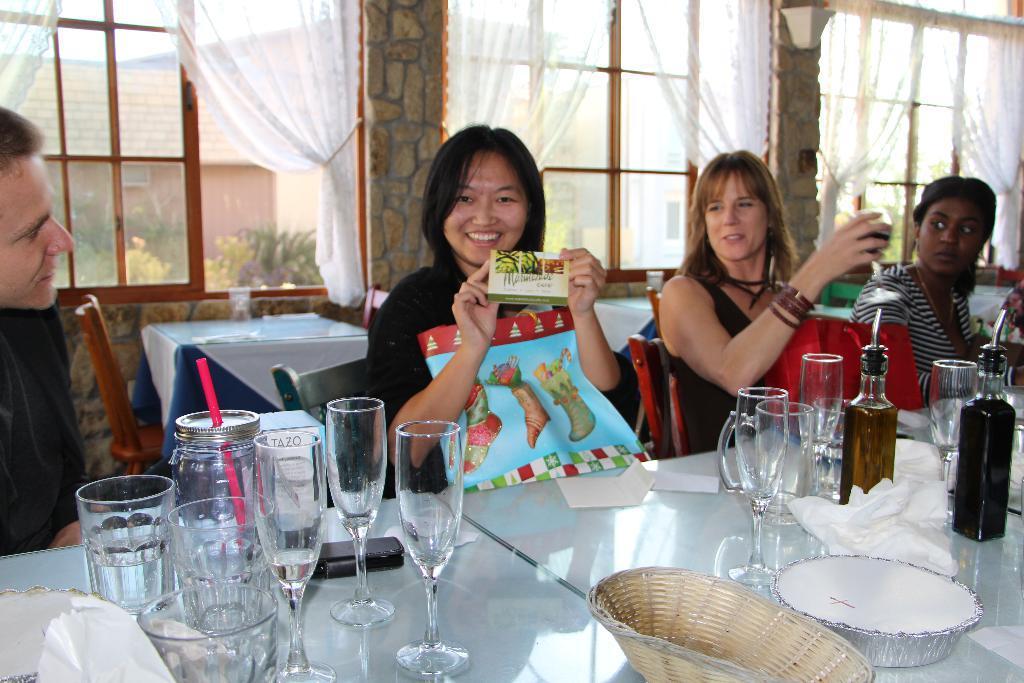In one or two sentences, can you explain what this image depicts? In this image there are dining table around it there are chairs. On chairs people are sitting. This lady is holding a packet she is smiling beside her a lady is holding a glass. On the table there are glasses, bottles, plate, basket, mug. In the background there are windows, curtains. Through the glass window we can see outside there are plants and building. 